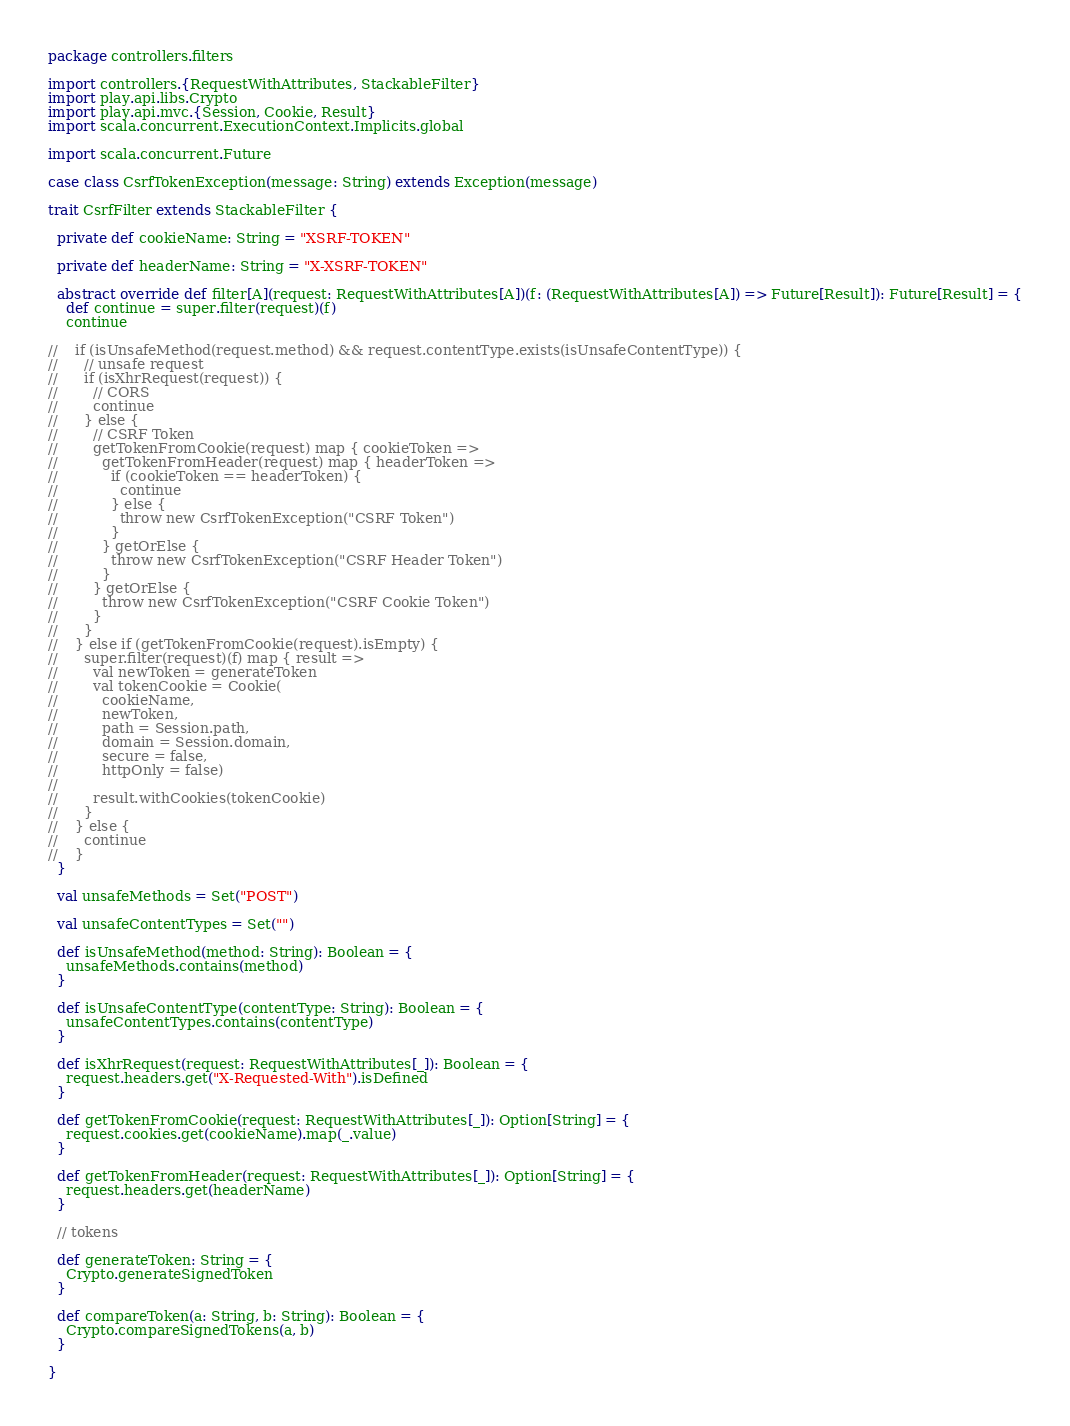<code> <loc_0><loc_0><loc_500><loc_500><_Scala_>package controllers.filters

import controllers.{RequestWithAttributes, StackableFilter}
import play.api.libs.Crypto
import play.api.mvc.{Session, Cookie, Result}
import scala.concurrent.ExecutionContext.Implicits.global

import scala.concurrent.Future

case class CsrfTokenException(message: String) extends Exception(message)

trait CsrfFilter extends StackableFilter {

  private def cookieName: String = "XSRF-TOKEN"

  private def headerName: String = "X-XSRF-TOKEN"

  abstract override def filter[A](request: RequestWithAttributes[A])(f: (RequestWithAttributes[A]) => Future[Result]): Future[Result] = {
    def continue = super.filter(request)(f)
    continue

//    if (isUnsafeMethod(request.method) && request.contentType.exists(isUnsafeContentType)) {
//      // unsafe request
//      if (isXhrRequest(request)) {
//        // CORS
//        continue
//      } else {
//        // CSRF Token
//        getTokenFromCookie(request) map { cookieToken =>
//          getTokenFromHeader(request) map { headerToken =>
//            if (cookieToken == headerToken) {
//              continue
//            } else {
//              throw new CsrfTokenException("CSRF Token")
//            }
//          } getOrElse {
//            throw new CsrfTokenException("CSRF Header Token")
//          }
//        } getOrElse {
//          throw new CsrfTokenException("CSRF Cookie Token")
//        }
//      }
//    } else if (getTokenFromCookie(request).isEmpty) {
//      super.filter(request)(f) map { result =>
//        val newToken = generateToken
//        val tokenCookie = Cookie(
//          cookieName,
//          newToken,
//          path = Session.path,
//          domain = Session.domain,
//          secure = false,
//          httpOnly = false)
//
//        result.withCookies(tokenCookie)
//      }
//    } else {
//      continue
//    }
  }

  val unsafeMethods = Set("POST")

  val unsafeContentTypes = Set("")

  def isUnsafeMethod(method: String): Boolean = {
    unsafeMethods.contains(method)
  }

  def isUnsafeContentType(contentType: String): Boolean = {
    unsafeContentTypes.contains(contentType)
  }

  def isXhrRequest(request: RequestWithAttributes[_]): Boolean = {
    request.headers.get("X-Requested-With").isDefined
  }

  def getTokenFromCookie(request: RequestWithAttributes[_]): Option[String] = {
    request.cookies.get(cookieName).map(_.value)
  }

  def getTokenFromHeader(request: RequestWithAttributes[_]): Option[String] = {
    request.headers.get(headerName)
  }

  // tokens

  def generateToken: String = {
    Crypto.generateSignedToken
  }

  def compareToken(a: String, b: String): Boolean = {
    Crypto.compareSignedTokens(a, b)
  }

}
</code> 